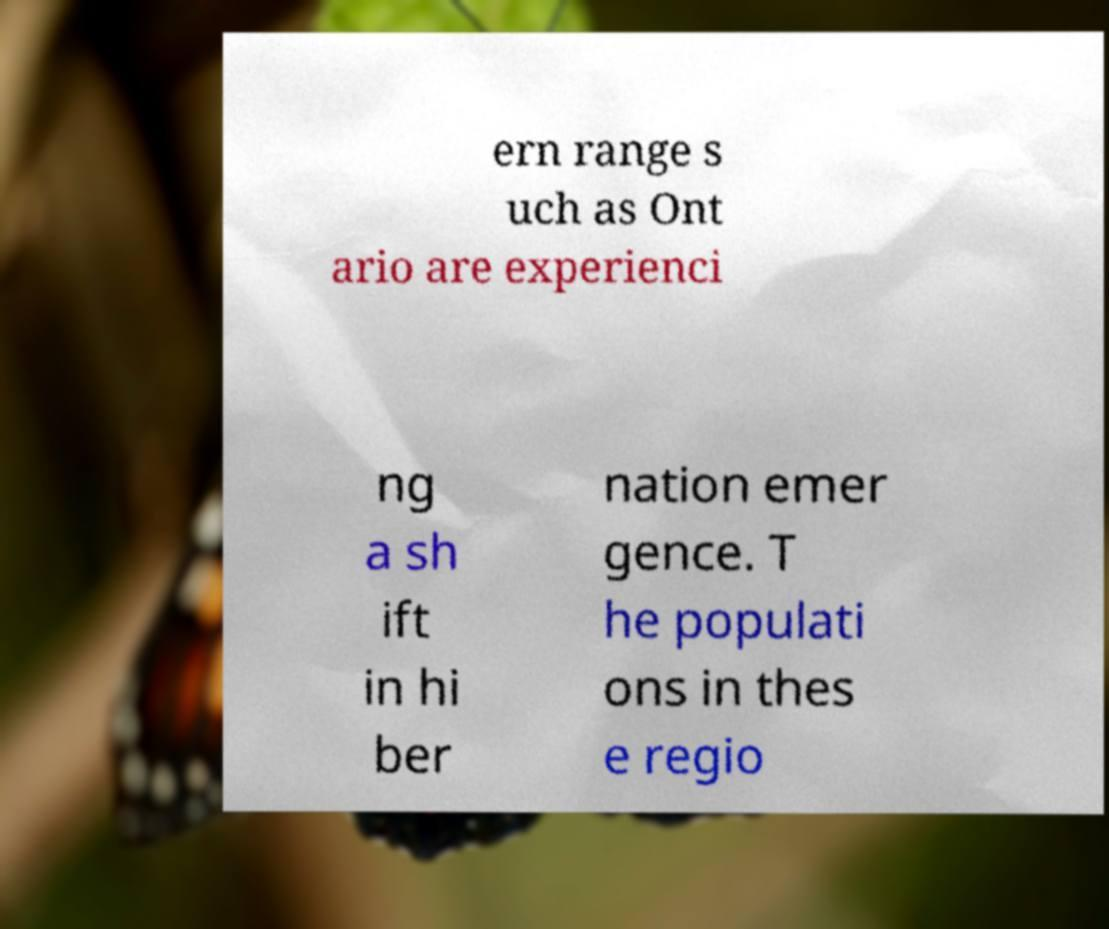I need the written content from this picture converted into text. Can you do that? ern range s uch as Ont ario are experienci ng a sh ift in hi ber nation emer gence. T he populati ons in thes e regio 